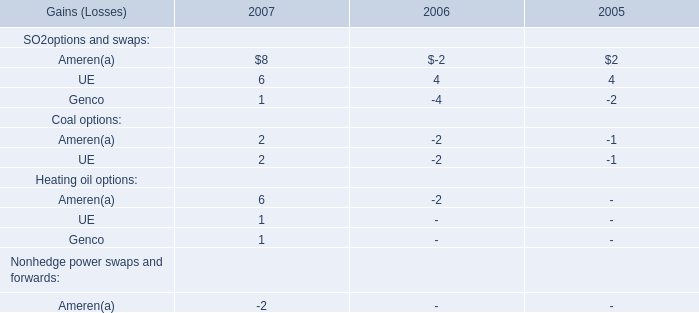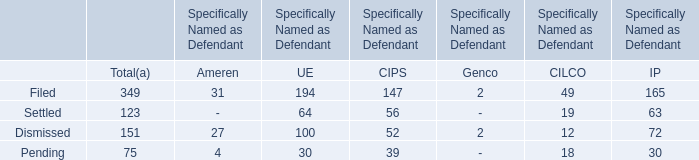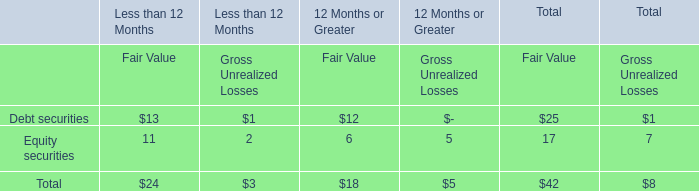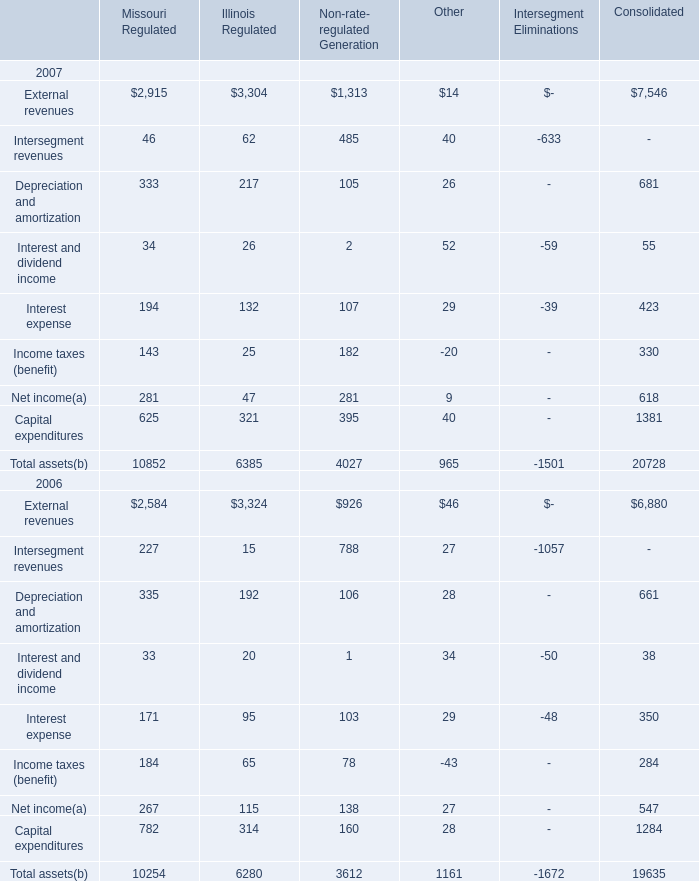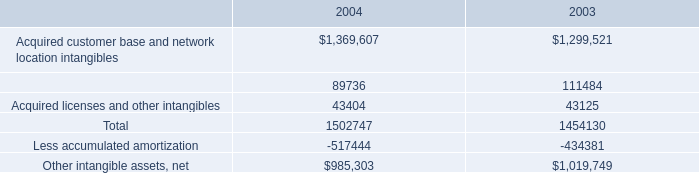What's the increasing rate of External revenues of Missouri Regulated in 2007? 
Computations: ((2915 - 2584) / 2584)
Answer: 0.1281. 